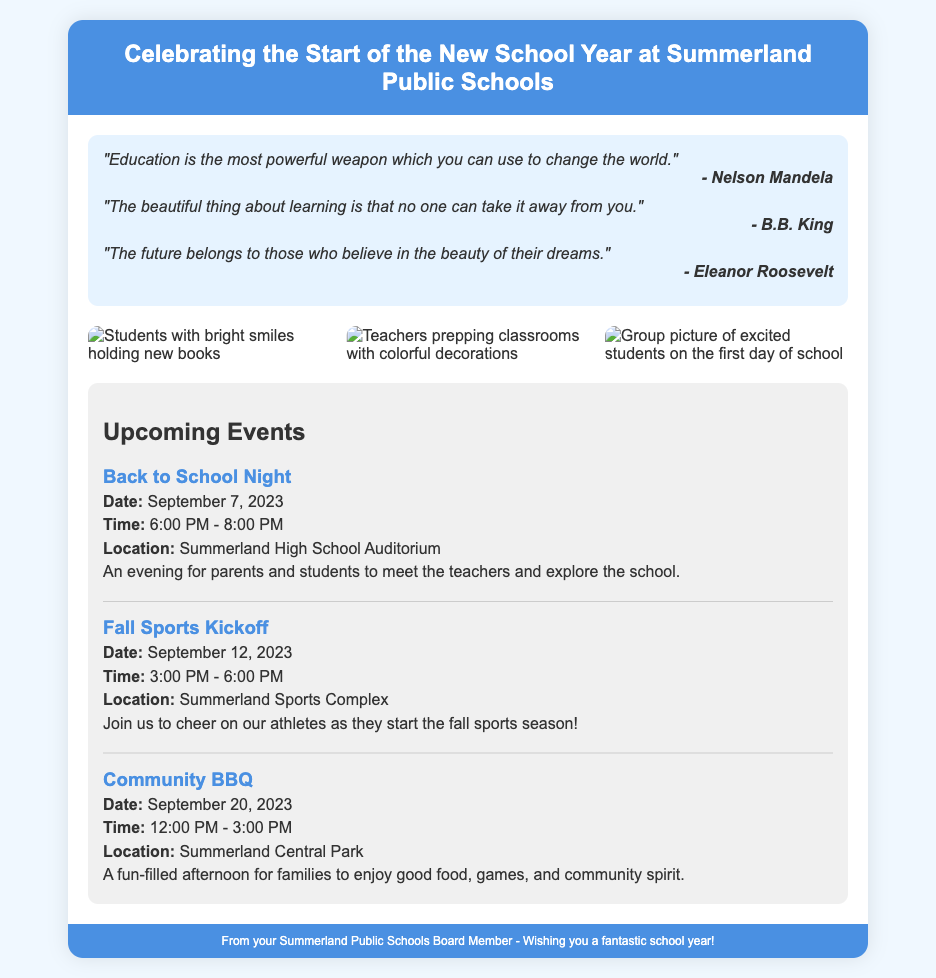what is the title of the document? The title of the document is specified in the <title> tag, which is "New School Year Celebration - Summerland Public Schools."
Answer: New School Year Celebration - Summerland Public Schools who is quoted in the first motivational quote? The first motivational quote is attributed to Nelson Mandela.
Answer: Nelson Mandela what is the date of the Back to School Night event? The date is mentioned in the content under upcoming events, specifically for the Back to School Night.
Answer: September 7, 2023 how many photos are included in the document? The document displays a total of three images within the photos section.
Answer: 3 what is the location for the Community BBQ? The location for the Community BBQ is specified in the details of the event.
Answer: Summerland Central Park why are motivational quotes included in the greeting card? The inclusion of motivational quotes enhances the celebratory theme and encourages positivity for the new school year.
Answer: To encourage positivity which event has the earliest date listed? The event with the earliest date is found in the upcoming events section.
Answer: Back to School Night what do the students in the photos hold? The students in the first photo are depicted holding new books.
Answer: New books who is the message in the footer from? The footer credits the card's message to the Summerland Public Schools Board Member.
Answer: Summerland Public Schools Board Member 